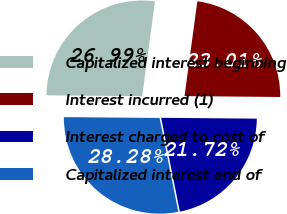<chart> <loc_0><loc_0><loc_500><loc_500><pie_chart><fcel>Capitalized interest beginning<fcel>Interest incurred (1)<fcel>Interest charged to cost of<fcel>Capitalized interest end of<nl><fcel>26.99%<fcel>23.01%<fcel>21.72%<fcel>28.28%<nl></chart> 